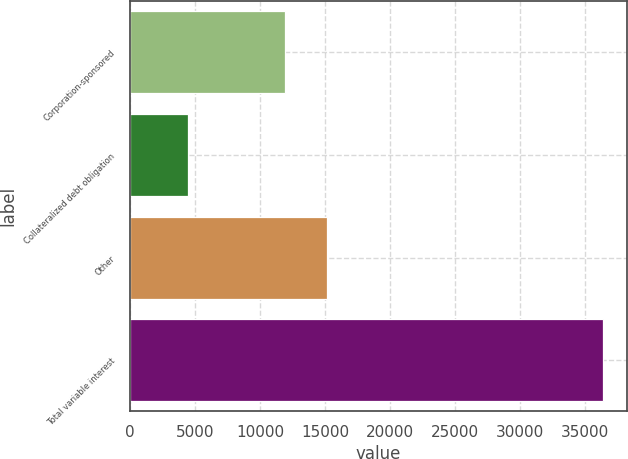Convert chart. <chart><loc_0><loc_0><loc_500><loc_500><bar_chart><fcel>Corporation-sponsored<fcel>Collateralized debt obligation<fcel>Other<fcel>Total variable interest<nl><fcel>11944<fcel>4464<fcel>15139.1<fcel>36415<nl></chart> 